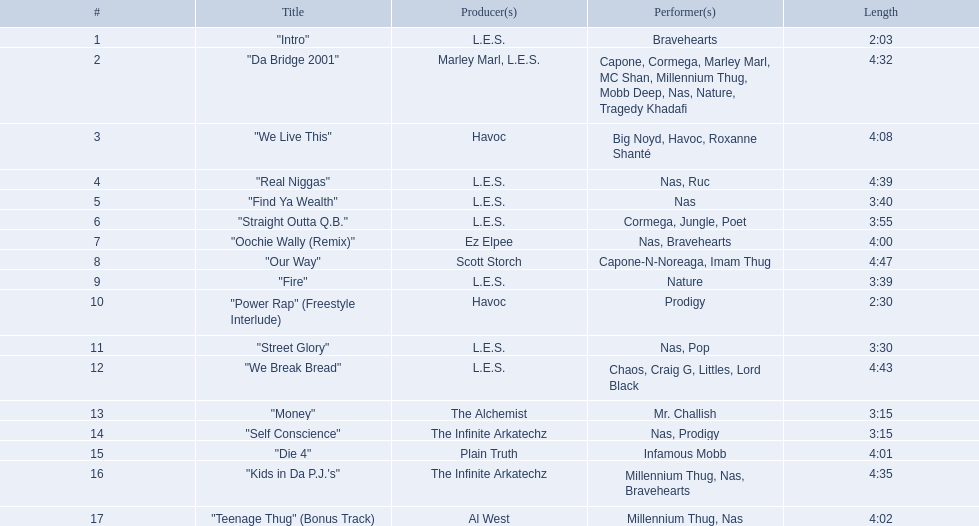What are the names of all the songs? "Intro", "Da Bridge 2001", "We Live This", "Real Niggas", "Find Ya Wealth", "Straight Outta Q.B.", "Oochie Wally (Remix)", "Our Way", "Fire", "Power Rap" (Freestyle Interlude), "Street Glory", "We Break Bread", "Money", "Self Conscience", "Die 4", "Kids in Da P.J.'s", "Teenage Thug" (Bonus Track). Who produced each of these songs? L.E.S., Marley Marl, L.E.S., Ez Elpee, Scott Storch, Havoc, The Alchemist, The Infinite Arkatechz, Plain Truth, Al West. Out of all the producers, who made the shortest song? L.E.S. What is the length of this producer's shortest song? 2:03. 